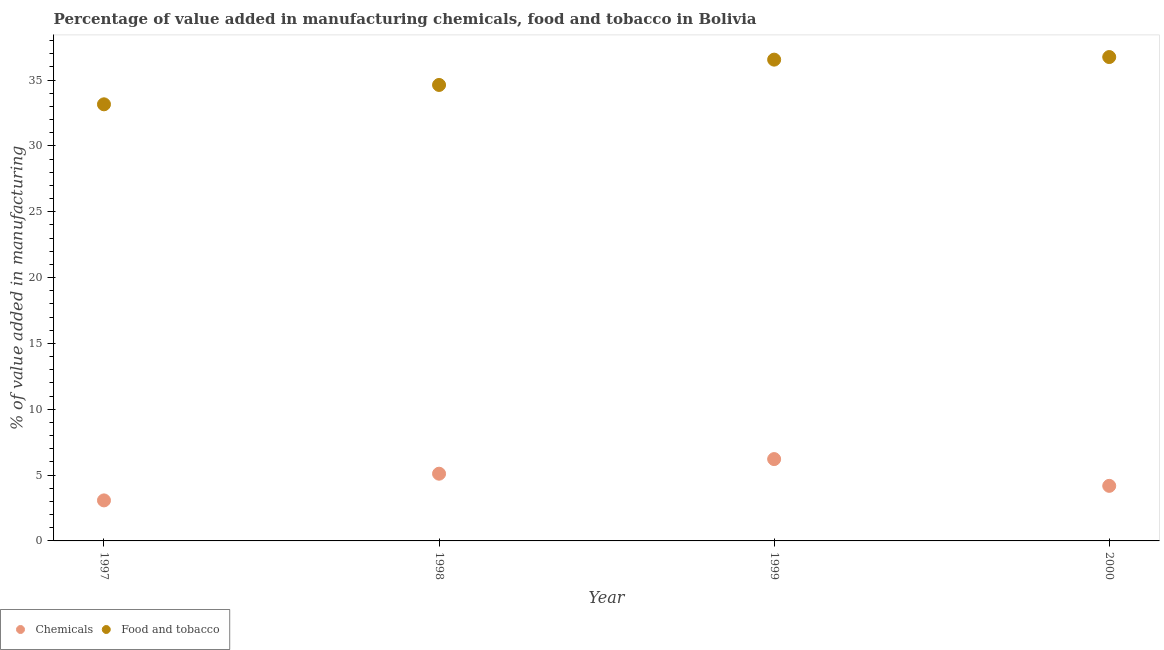What is the value added by  manufacturing chemicals in 1998?
Provide a succinct answer. 5.11. Across all years, what is the maximum value added by manufacturing food and tobacco?
Give a very brief answer. 36.75. Across all years, what is the minimum value added by  manufacturing chemicals?
Provide a succinct answer. 3.08. In which year was the value added by manufacturing food and tobacco maximum?
Your answer should be compact. 2000. In which year was the value added by  manufacturing chemicals minimum?
Your response must be concise. 1997. What is the total value added by manufacturing food and tobacco in the graph?
Your answer should be compact. 141.1. What is the difference between the value added by manufacturing food and tobacco in 1998 and that in 1999?
Offer a very short reply. -1.92. What is the difference between the value added by  manufacturing chemicals in 1997 and the value added by manufacturing food and tobacco in 1999?
Offer a terse response. -33.48. What is the average value added by manufacturing food and tobacco per year?
Your response must be concise. 35.28. In the year 1998, what is the difference between the value added by  manufacturing chemicals and value added by manufacturing food and tobacco?
Keep it short and to the point. -29.53. In how many years, is the value added by  manufacturing chemicals greater than 24 %?
Give a very brief answer. 0. What is the ratio of the value added by manufacturing food and tobacco in 1997 to that in 1999?
Make the answer very short. 0.91. What is the difference between the highest and the second highest value added by  manufacturing chemicals?
Offer a very short reply. 1.11. What is the difference between the highest and the lowest value added by manufacturing food and tobacco?
Make the answer very short. 3.59. Is the sum of the value added by manufacturing food and tobacco in 1999 and 2000 greater than the maximum value added by  manufacturing chemicals across all years?
Your response must be concise. Yes. Is the value added by manufacturing food and tobacco strictly greater than the value added by  manufacturing chemicals over the years?
Offer a very short reply. Yes. How many dotlines are there?
Make the answer very short. 2. What is the difference between two consecutive major ticks on the Y-axis?
Keep it short and to the point. 5. Are the values on the major ticks of Y-axis written in scientific E-notation?
Provide a short and direct response. No. Does the graph contain any zero values?
Ensure brevity in your answer.  No. Where does the legend appear in the graph?
Keep it short and to the point. Bottom left. How many legend labels are there?
Make the answer very short. 2. What is the title of the graph?
Provide a succinct answer. Percentage of value added in manufacturing chemicals, food and tobacco in Bolivia. What is the label or title of the Y-axis?
Offer a very short reply. % of value added in manufacturing. What is the % of value added in manufacturing in Chemicals in 1997?
Make the answer very short. 3.08. What is the % of value added in manufacturing of Food and tobacco in 1997?
Keep it short and to the point. 33.16. What is the % of value added in manufacturing in Chemicals in 1998?
Your response must be concise. 5.11. What is the % of value added in manufacturing of Food and tobacco in 1998?
Your answer should be very brief. 34.63. What is the % of value added in manufacturing of Chemicals in 1999?
Make the answer very short. 6.22. What is the % of value added in manufacturing in Food and tobacco in 1999?
Ensure brevity in your answer.  36.56. What is the % of value added in manufacturing in Chemicals in 2000?
Offer a very short reply. 4.18. What is the % of value added in manufacturing of Food and tobacco in 2000?
Your answer should be compact. 36.75. Across all years, what is the maximum % of value added in manufacturing in Chemicals?
Make the answer very short. 6.22. Across all years, what is the maximum % of value added in manufacturing in Food and tobacco?
Offer a terse response. 36.75. Across all years, what is the minimum % of value added in manufacturing of Chemicals?
Offer a terse response. 3.08. Across all years, what is the minimum % of value added in manufacturing of Food and tobacco?
Provide a succinct answer. 33.16. What is the total % of value added in manufacturing of Chemicals in the graph?
Ensure brevity in your answer.  18.58. What is the total % of value added in manufacturing in Food and tobacco in the graph?
Ensure brevity in your answer.  141.1. What is the difference between the % of value added in manufacturing of Chemicals in 1997 and that in 1998?
Your answer should be very brief. -2.03. What is the difference between the % of value added in manufacturing in Food and tobacco in 1997 and that in 1998?
Give a very brief answer. -1.47. What is the difference between the % of value added in manufacturing in Chemicals in 1997 and that in 1999?
Make the answer very short. -3.14. What is the difference between the % of value added in manufacturing of Food and tobacco in 1997 and that in 1999?
Your answer should be very brief. -3.39. What is the difference between the % of value added in manufacturing in Chemicals in 1997 and that in 2000?
Your answer should be very brief. -1.1. What is the difference between the % of value added in manufacturing in Food and tobacco in 1997 and that in 2000?
Ensure brevity in your answer.  -3.59. What is the difference between the % of value added in manufacturing of Chemicals in 1998 and that in 1999?
Provide a short and direct response. -1.11. What is the difference between the % of value added in manufacturing in Food and tobacco in 1998 and that in 1999?
Offer a very short reply. -1.92. What is the difference between the % of value added in manufacturing in Chemicals in 1998 and that in 2000?
Give a very brief answer. 0.92. What is the difference between the % of value added in manufacturing of Food and tobacco in 1998 and that in 2000?
Give a very brief answer. -2.12. What is the difference between the % of value added in manufacturing in Chemicals in 1999 and that in 2000?
Offer a very short reply. 2.03. What is the difference between the % of value added in manufacturing of Food and tobacco in 1999 and that in 2000?
Provide a succinct answer. -0.2. What is the difference between the % of value added in manufacturing of Chemicals in 1997 and the % of value added in manufacturing of Food and tobacco in 1998?
Your response must be concise. -31.56. What is the difference between the % of value added in manufacturing in Chemicals in 1997 and the % of value added in manufacturing in Food and tobacco in 1999?
Give a very brief answer. -33.48. What is the difference between the % of value added in manufacturing in Chemicals in 1997 and the % of value added in manufacturing in Food and tobacco in 2000?
Offer a terse response. -33.68. What is the difference between the % of value added in manufacturing of Chemicals in 1998 and the % of value added in manufacturing of Food and tobacco in 1999?
Give a very brief answer. -31.45. What is the difference between the % of value added in manufacturing in Chemicals in 1998 and the % of value added in manufacturing in Food and tobacco in 2000?
Make the answer very short. -31.65. What is the difference between the % of value added in manufacturing in Chemicals in 1999 and the % of value added in manufacturing in Food and tobacco in 2000?
Your response must be concise. -30.54. What is the average % of value added in manufacturing of Chemicals per year?
Make the answer very short. 4.65. What is the average % of value added in manufacturing of Food and tobacco per year?
Provide a succinct answer. 35.28. In the year 1997, what is the difference between the % of value added in manufacturing of Chemicals and % of value added in manufacturing of Food and tobacco?
Give a very brief answer. -30.08. In the year 1998, what is the difference between the % of value added in manufacturing of Chemicals and % of value added in manufacturing of Food and tobacco?
Offer a terse response. -29.53. In the year 1999, what is the difference between the % of value added in manufacturing of Chemicals and % of value added in manufacturing of Food and tobacco?
Provide a short and direct response. -30.34. In the year 2000, what is the difference between the % of value added in manufacturing of Chemicals and % of value added in manufacturing of Food and tobacco?
Your answer should be compact. -32.57. What is the ratio of the % of value added in manufacturing of Chemicals in 1997 to that in 1998?
Ensure brevity in your answer.  0.6. What is the ratio of the % of value added in manufacturing in Food and tobacco in 1997 to that in 1998?
Offer a terse response. 0.96. What is the ratio of the % of value added in manufacturing of Chemicals in 1997 to that in 1999?
Offer a very short reply. 0.5. What is the ratio of the % of value added in manufacturing in Food and tobacco in 1997 to that in 1999?
Give a very brief answer. 0.91. What is the ratio of the % of value added in manufacturing in Chemicals in 1997 to that in 2000?
Give a very brief answer. 0.74. What is the ratio of the % of value added in manufacturing in Food and tobacco in 1997 to that in 2000?
Your response must be concise. 0.9. What is the ratio of the % of value added in manufacturing of Chemicals in 1998 to that in 1999?
Offer a very short reply. 0.82. What is the ratio of the % of value added in manufacturing in Chemicals in 1998 to that in 2000?
Ensure brevity in your answer.  1.22. What is the ratio of the % of value added in manufacturing in Food and tobacco in 1998 to that in 2000?
Your answer should be compact. 0.94. What is the ratio of the % of value added in manufacturing in Chemicals in 1999 to that in 2000?
Provide a succinct answer. 1.49. What is the ratio of the % of value added in manufacturing of Food and tobacco in 1999 to that in 2000?
Offer a very short reply. 0.99. What is the difference between the highest and the second highest % of value added in manufacturing of Chemicals?
Give a very brief answer. 1.11. What is the difference between the highest and the second highest % of value added in manufacturing of Food and tobacco?
Your response must be concise. 0.2. What is the difference between the highest and the lowest % of value added in manufacturing of Chemicals?
Provide a short and direct response. 3.14. What is the difference between the highest and the lowest % of value added in manufacturing of Food and tobacco?
Ensure brevity in your answer.  3.59. 